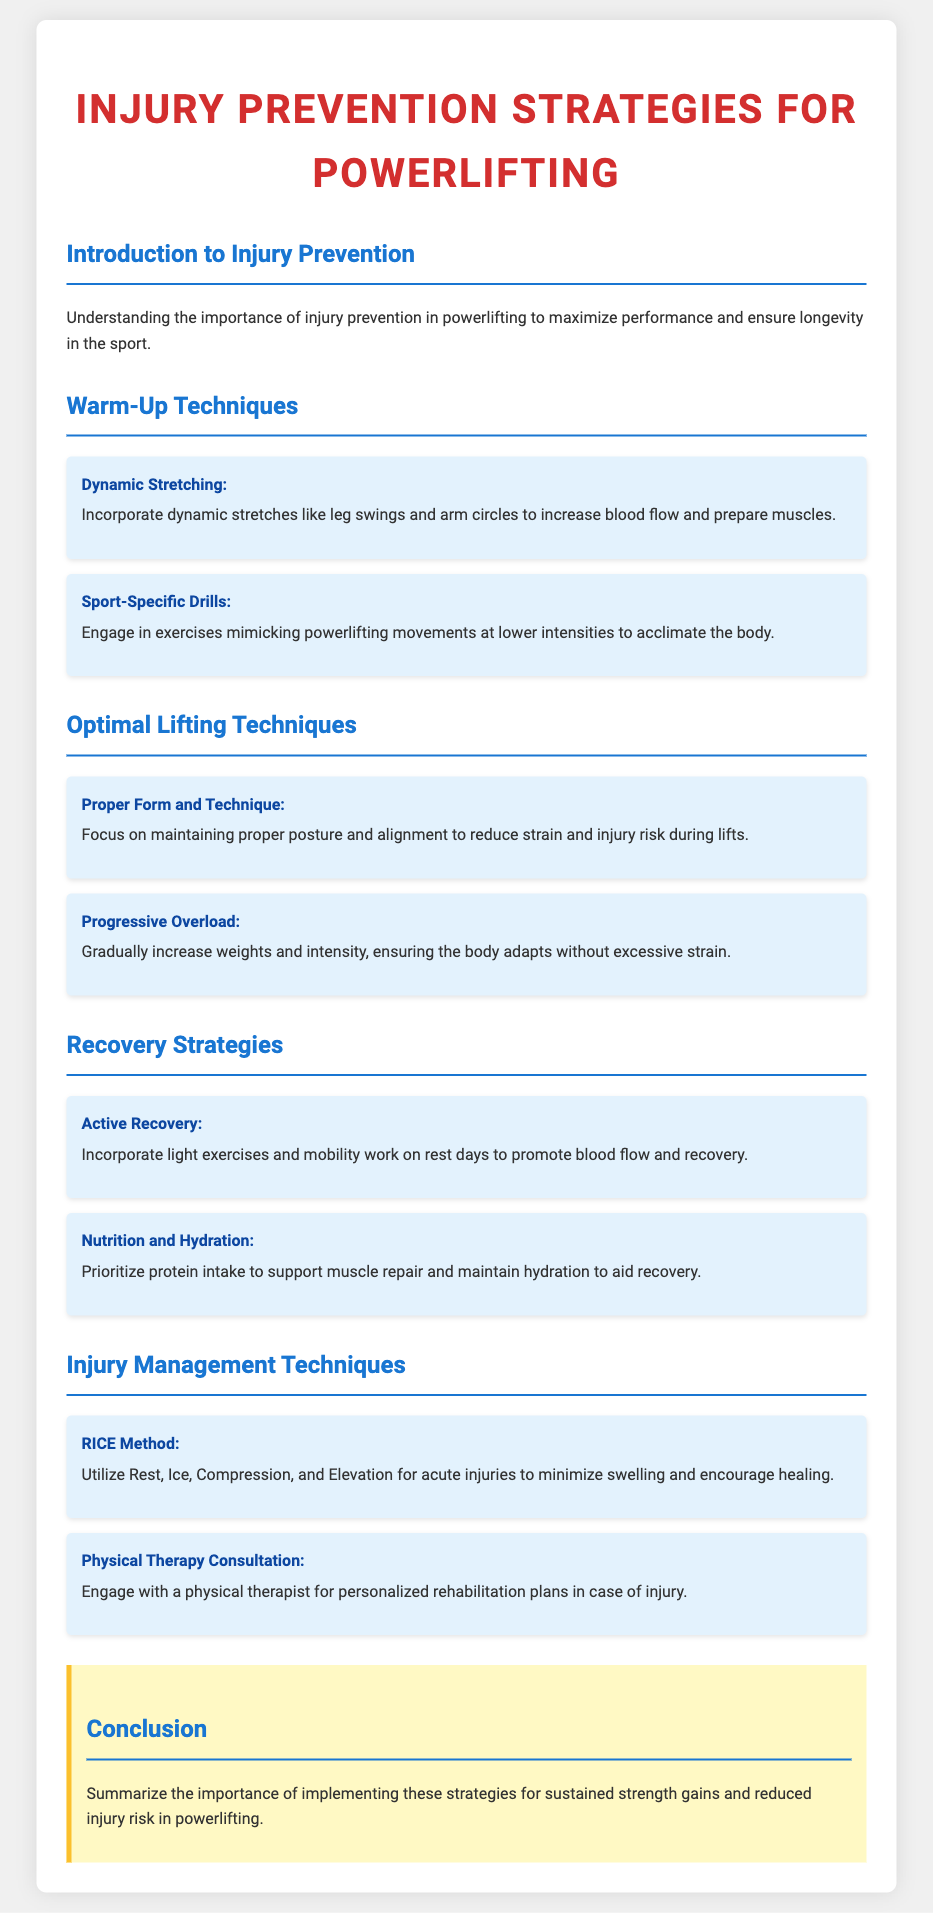What is the title of the document? The title is found in the header section of the document, which states "Injury Prevention Strategies for Powerlifting."
Answer: Injury Prevention Strategies for Powerlifting What are the two types of warm-up techniques mentioned? The document lists warm-up techniques under a specific section, which includes "Dynamic Stretching" and "Sport-Specific Drills."
Answer: Dynamic Stretching, Sport-Specific Drills What is the focus of proper lifting techniques? Proper lifting techniques are emphasized in the document to ensure safety and performance during lifts, specifically focusing on "maintaining proper posture and alignment."
Answer: Proper posture and alignment What is the first recovery strategy described? The document presents a recovery strategy section, wherein the first strategy mentioned is "Active Recovery."
Answer: Active Recovery What does the RICE method stand for? The document outlines injury management techniques, with the RICE method specified as "Rest, Ice, Compression, Elevation."
Answer: Rest, Ice, Compression, Elevation How does the document emphasize the importance of nutrition? Nutrition's role is highlighted in the recovery strategies, specifically mentioning "Prioritize protein intake to support muscle repair."
Answer: Prioritize protein intake What should you do on rest days according to recovery strategies? The document suggests incorporating "light exercises and mobility work" on rest days to facilitate recovery.
Answer: Light exercises and mobility work What color is used for the conclusion section's background? The document specifies the background color for the conclusion, which is described as "background-color: #fff9c4."
Answer: #fff9c4 